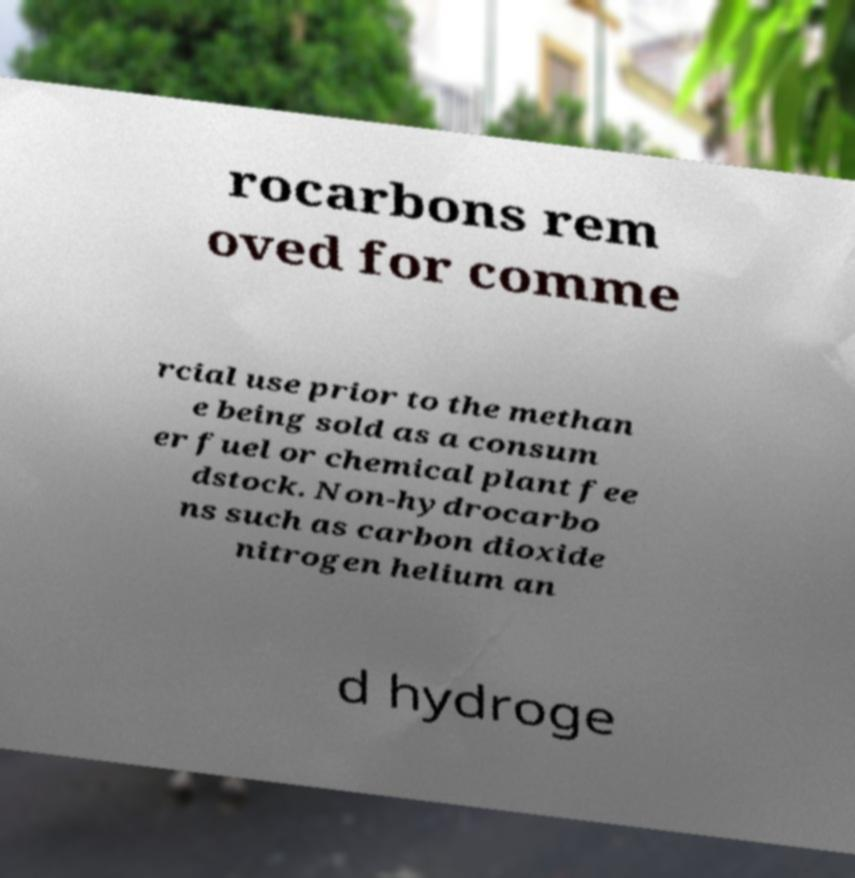Can you accurately transcribe the text from the provided image for me? rocarbons rem oved for comme rcial use prior to the methan e being sold as a consum er fuel or chemical plant fee dstock. Non-hydrocarbo ns such as carbon dioxide nitrogen helium an d hydroge 